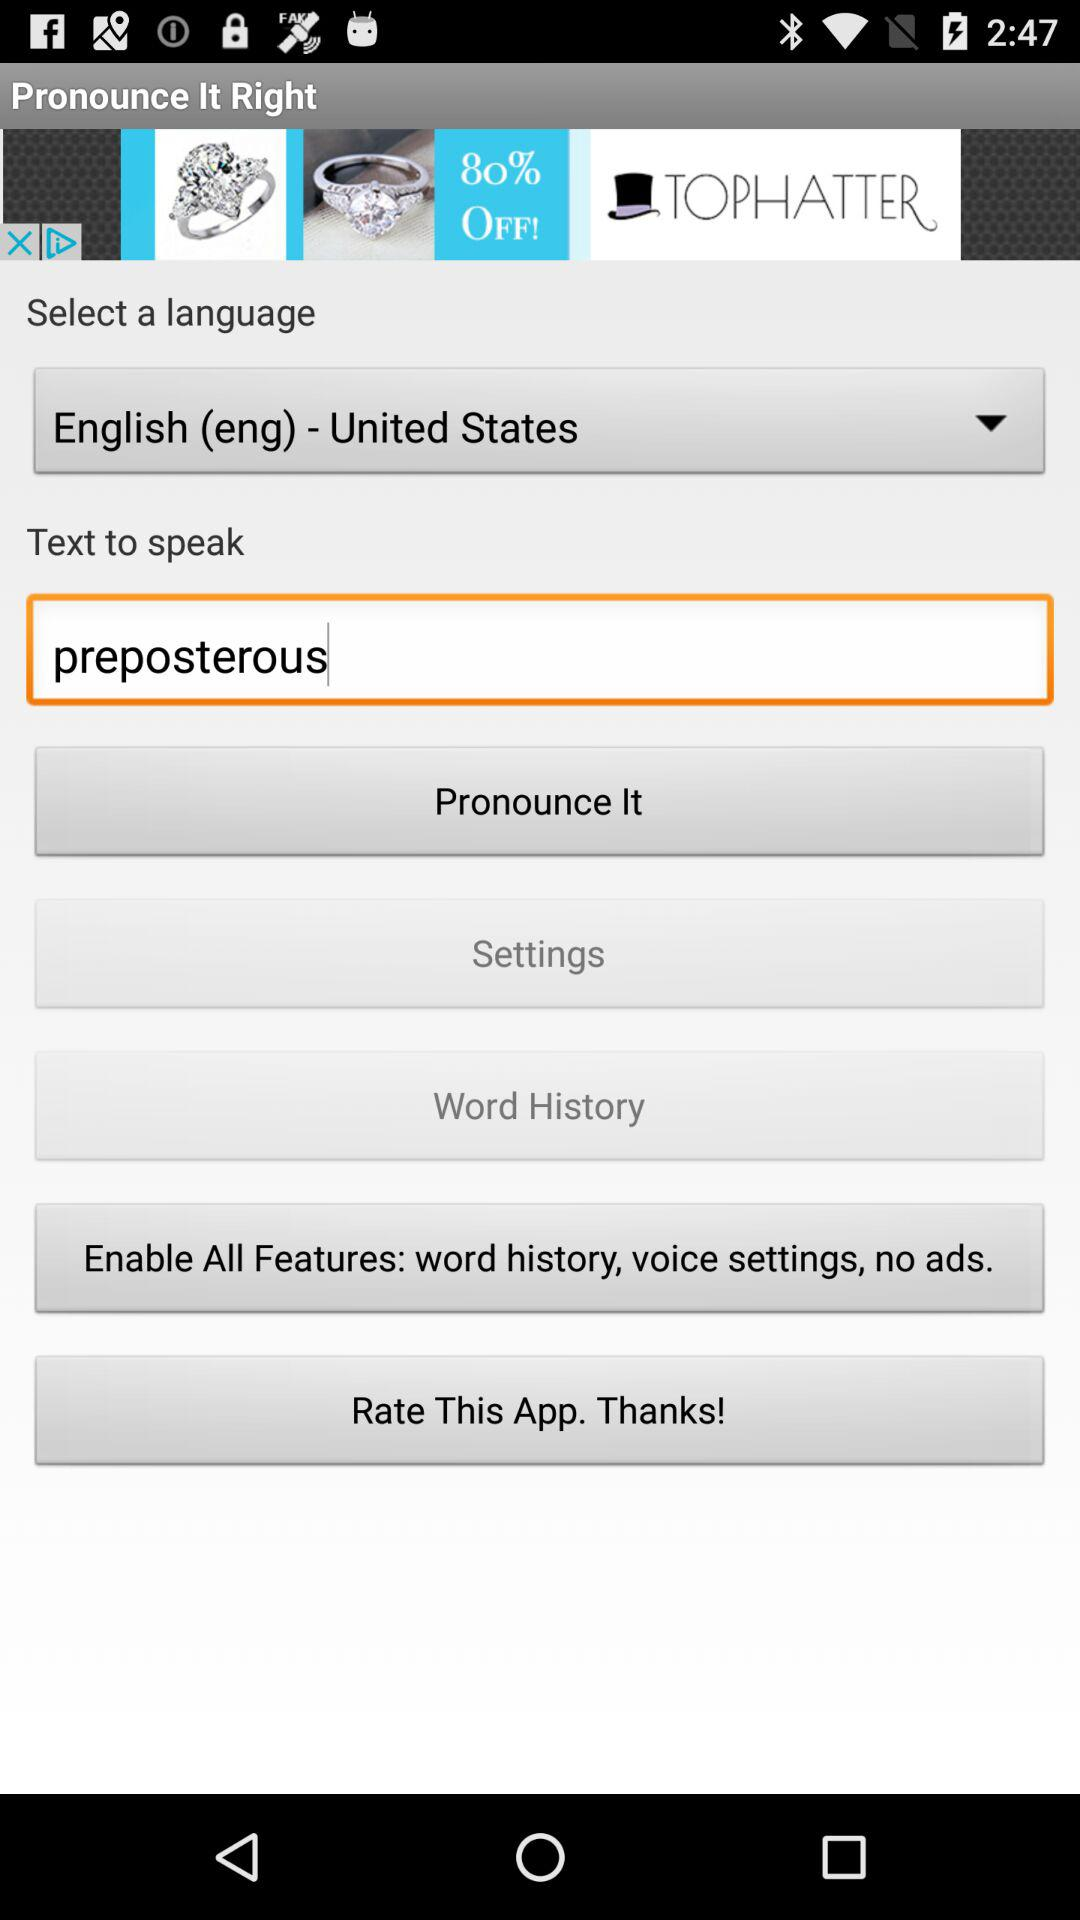What is the text entered for pronunciation? The text entered for pronunciation is "preposterous". 